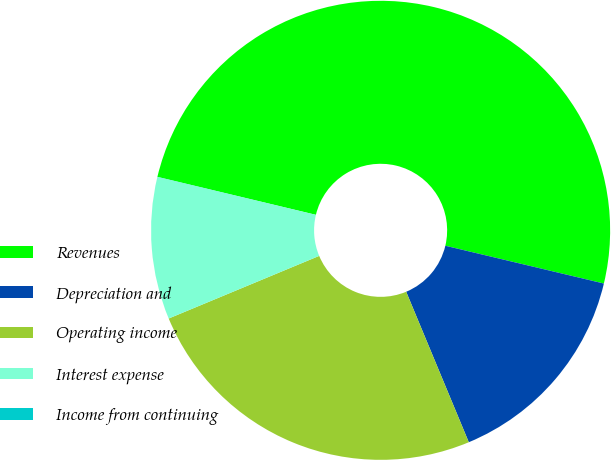Convert chart. <chart><loc_0><loc_0><loc_500><loc_500><pie_chart><fcel>Revenues<fcel>Depreciation and<fcel>Operating income<fcel>Interest expense<fcel>Income from continuing<nl><fcel>49.98%<fcel>15.0%<fcel>25.0%<fcel>10.01%<fcel>0.01%<nl></chart> 